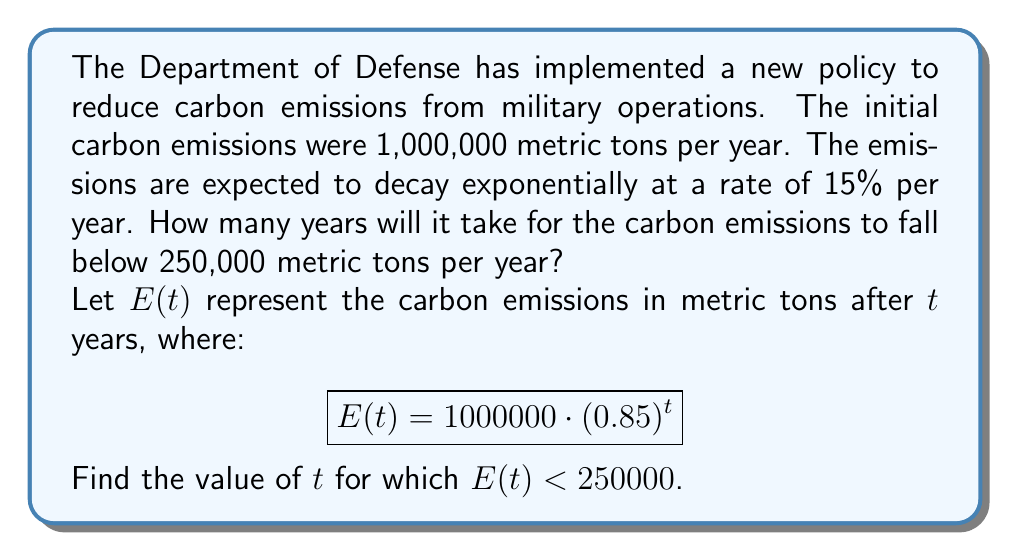Could you help me with this problem? To solve this problem, we need to use the exponential decay function and solve an inequality. Let's approach this step-by-step:

1) We start with the given exponential decay function:
   $$E(t) = 1000000 \cdot (0.85)^t$$

2) We want to find when this becomes less than 250,000:
   $$1000000 \cdot (0.85)^t < 250000$$

3) Divide both sides by 1,000,000:
   $$(0.85)^t < 0.25$$

4) Take the natural logarithm of both sides:
   $$\ln((0.85)^t) < \ln(0.25)$$

5) Use the logarithm property $\ln(a^b) = b\ln(a)$:
   $$t \cdot \ln(0.85) < \ln(0.25)$$

6) Divide both sides by $\ln(0.85)$ (note that $\ln(0.85)$ is negative, so the inequality sign flips):
   $$t > \frac{\ln(0.25)}{\ln(0.85)}$$

7) Calculate the right side:
   $$t > \frac{\ln(0.25)}{\ln(0.85)} \approx 8.9758$$

8) Since $t$ represents years and must be a whole number, we need to round up to the next integer.
Answer: It will take 9 years for the carbon emissions to fall below 250,000 metric tons per year. 